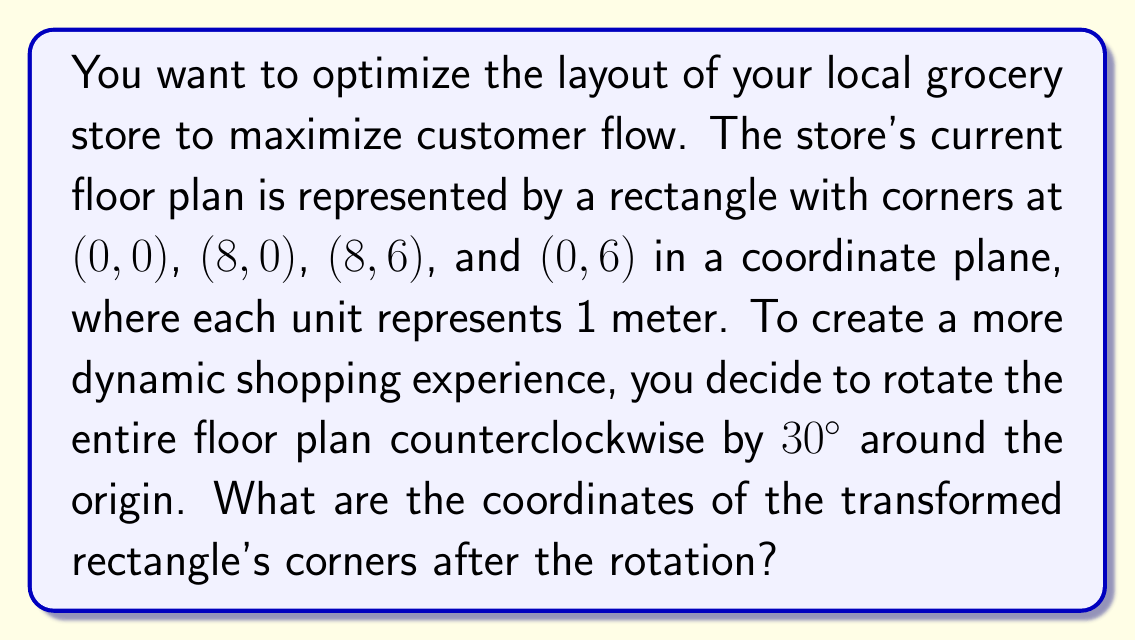Help me with this question. To solve this problem, we'll use the rotation matrix for a counterclockwise rotation by 30°. The steps are as follows:

1. Recall the rotation matrix for a counterclockwise rotation by angle θ:
   $$R_\theta = \begin{pmatrix} \cos\theta & -\sin\theta \\ \sin\theta & \cos\theta \end{pmatrix}$$

2. For 30°, we have:
   $$R_{30°} = \begin{pmatrix} \cos30° & -\sin30° \\ \sin30° & \cos30° \end{pmatrix} = \begin{pmatrix} \frac{\sqrt{3}}{2} & -\frac{1}{2} \\ \frac{1}{2} & \frac{\sqrt{3}}{2} \end{pmatrix}$$

3. To rotate a point $(x, y)$, we multiply the rotation matrix by the column vector of the point:
   $$\begin{pmatrix} x' \\ y' \end{pmatrix} = \begin{pmatrix} \frac{\sqrt{3}}{2} & -\frac{1}{2} \\ \frac{1}{2} & \frac{\sqrt{3}}{2} \end{pmatrix} \begin{pmatrix} x \\ y \end{pmatrix}$$

4. Let's rotate each corner:

   For (0, 0):
   $$\begin{pmatrix} 0 \\ 0 \end{pmatrix} = \begin{pmatrix} 0 \\ 0 \end{pmatrix}$$

   For (8, 0):
   $$\begin{pmatrix} 8\frac{\sqrt{3}}{2} \\ 8\frac{1}{2} \end{pmatrix} = \begin{pmatrix} 4\sqrt{3} \\ 4 \end{pmatrix}$$

   For (8, 6):
   $$\begin{pmatrix} 8\frac{\sqrt{3}}{2} - 6\frac{1}{2} \\ 8\frac{1}{2} + 6\frac{\sqrt{3}}{2} \end{pmatrix} = \begin{pmatrix} 4\sqrt{3} - 3 \\ 4 + 3\sqrt{3} \end{pmatrix}$$

   For (0, 6):
   $$\begin{pmatrix} -6\frac{1}{2} \\ 6\frac{\sqrt{3}}{2} \end{pmatrix} = \begin{pmatrix} -3 \\ 3\sqrt{3} \end{pmatrix}$$

5. Therefore, the coordinates of the transformed rectangle's corners are:
   (0, 0), $(4\sqrt{3}, 4)$, $(4\sqrt{3} - 3, 4 + 3\sqrt{3})$, and $(-3, 3\sqrt{3})$.
Answer: (0, 0), $(4\sqrt{3}, 4)$, $(4\sqrt{3} - 3, 4 + 3\sqrt{3})$, $(-3, 3\sqrt{3})$ 